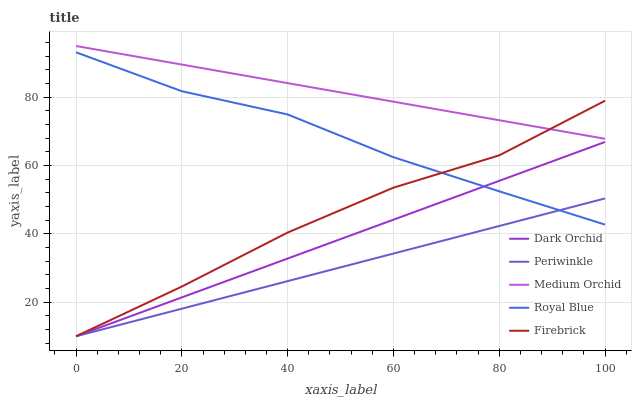Does Periwinkle have the minimum area under the curve?
Answer yes or no. Yes. Does Medium Orchid have the maximum area under the curve?
Answer yes or no. Yes. Does Firebrick have the minimum area under the curve?
Answer yes or no. No. Does Firebrick have the maximum area under the curve?
Answer yes or no. No. Is Periwinkle the smoothest?
Answer yes or no. Yes. Is Firebrick the roughest?
Answer yes or no. Yes. Is Medium Orchid the smoothest?
Answer yes or no. No. Is Medium Orchid the roughest?
Answer yes or no. No. Does Medium Orchid have the lowest value?
Answer yes or no. No. Does Firebrick have the highest value?
Answer yes or no. No. Is Royal Blue less than Medium Orchid?
Answer yes or no. Yes. Is Medium Orchid greater than Periwinkle?
Answer yes or no. Yes. Does Royal Blue intersect Medium Orchid?
Answer yes or no. No. 